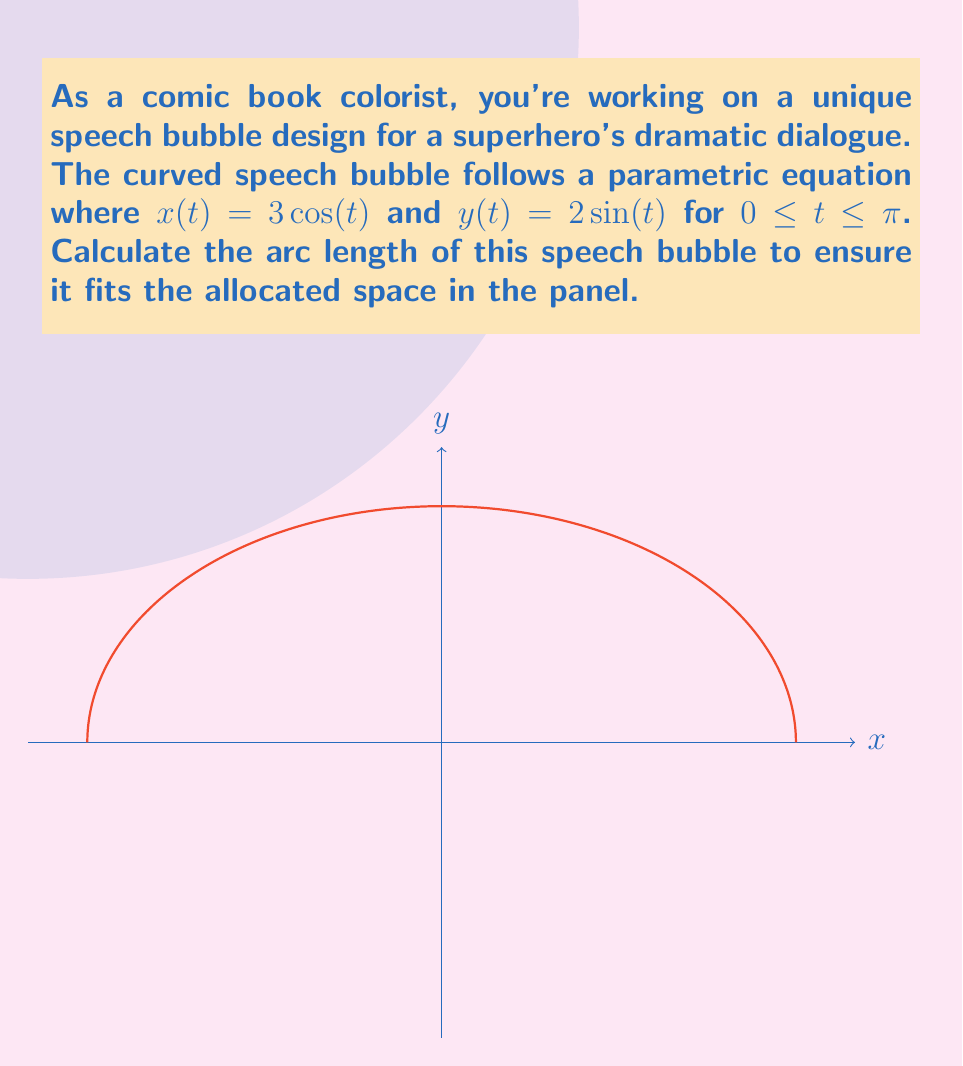Give your solution to this math problem. To calculate the arc length of a curve defined by parametric equations, we use the formula:

$$L = \int_a^b \sqrt{\left(\frac{dx}{dt}\right)^2 + \left(\frac{dy}{dt}\right)^2} dt$$

Step 1: Find $\frac{dx}{dt}$ and $\frac{dy}{dt}$
$\frac{dx}{dt} = -3\sin(t)$
$\frac{dy}{dt} = 2\cos(t)$

Step 2: Substitute into the arc length formula
$$L = \int_0^\pi \sqrt{(-3\sin(t))^2 + (2\cos(t))^2} dt$$

Step 3: Simplify under the square root
$$L = \int_0^\pi \sqrt{9\sin^2(t) + 4\cos^2(t)} dt$$

Step 4: Factor out the common term
$$L = \int_0^\pi \sqrt{4(\frac{9}{4}\sin^2(t) + \cos^2(t))} dt$$

Step 5: Recognize the identity $\sin^2(t) + \cos^2(t) = 1$
$$L = \int_0^\pi \sqrt{4(\frac{9}{4}\sin^2(t) + \cos^2(t))} dt = \int_0^\pi \sqrt{4(\frac{5}{4}\sin^2(t) + 1)} dt$$

Step 6: Simplify
$$L = \int_0^\pi 2\sqrt{\frac{5}{4}\sin^2(t) + 1} dt$$

Step 7: This integral doesn't have an elementary antiderivative. We need to use numerical methods or elliptic integrals to evaluate it. Using numerical integration, we get:

$$L \approx 7.64$$
Answer: $7.64$ units 